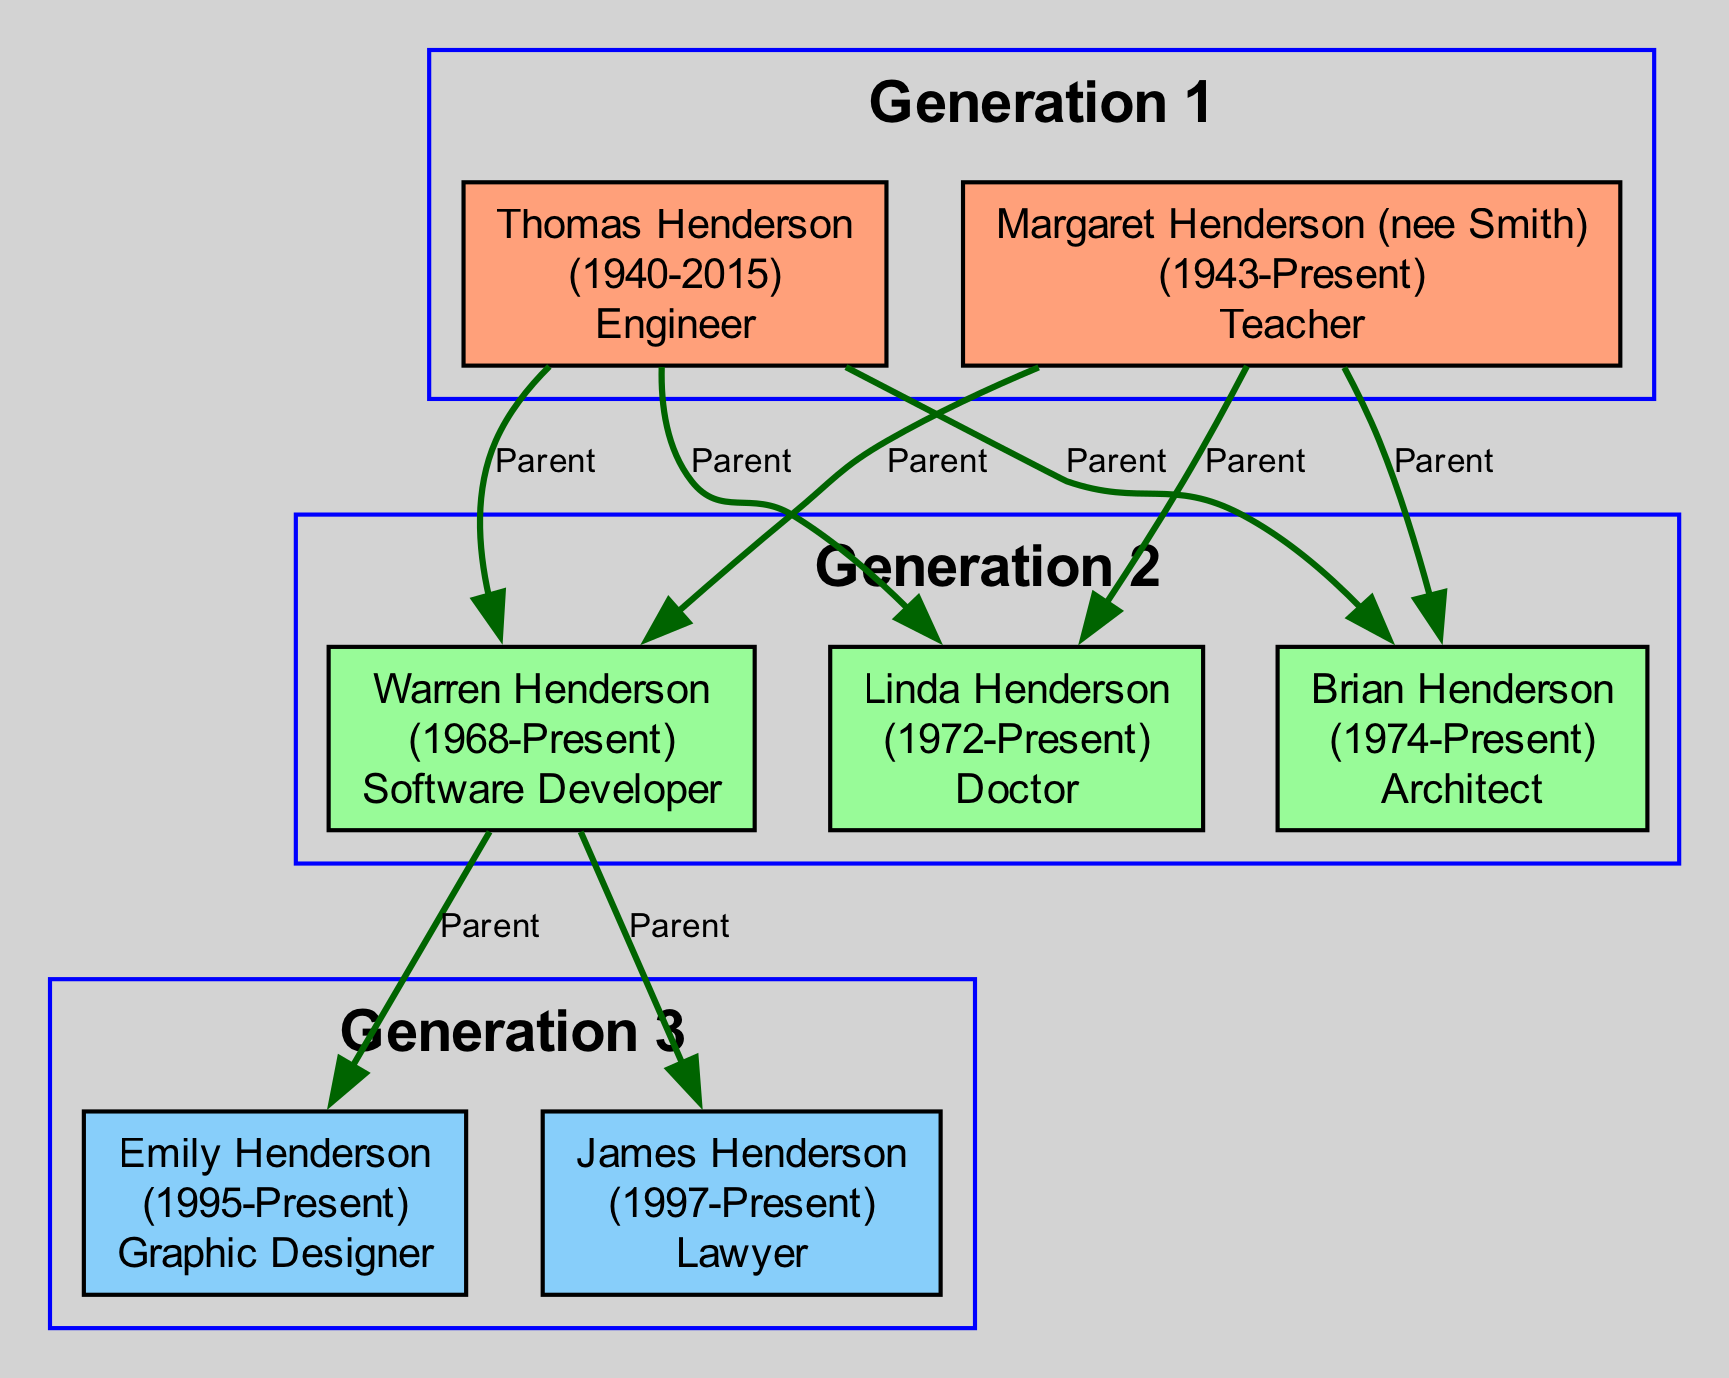What is the birth year of Thomas Henderson? The diagram indicates that Thomas Henderson was born in 1940, which is provided in the node details for his name.
Answer: 1940 Who is the matriarch of the Henderson family? In the diagram, the person labeled as the matriarch is Margaret Henderson, as indicated in her node under generation one.
Answer: Margaret Henderson (nee Smith) How many members are in the second generation of the Henderson family? By counting the nodes in the generation two section, there are three members: Warren, Linda, and Brian Henderson.
Answer: 3 What occupation does Emily Henderson have? The occupation of Emily Henderson is mentioned in her node as "Graphic Designer," which is prominently displayed along with her other details.
Answer: Graphic Designer What is the relationship between Warren Henderson and Emily Henderson? The diagram shows an edge labeled "Parent" connecting Warren Henderson to Emily Henderson, indicating that Warren is her parent.
Answer: Parent How many generations are represented in the family tree? The diagram distinguishes three sections labeled as "Generation 1," "Generation 2," and "Generation 3," which explicitly indicates there are three generations in total.
Answer: 3 Which member of the family tree is a pediatrician? From the information in the diagram, Linda Henderson is identified as a pediatrician in her node details under generation two.
Answer: Linda Henderson Who is known for modern architectural designs? The diagram attributes the occupation of architect to Brian Henderson, highlighting his significance in modern architectural designs in his node.
Answer: Brian Henderson Which family member is noted for their contributions to cyber law? The node for James Henderson in generation three states that he specializes in cyber law, marking him for his contributions in that field.
Answer: James Henderson 